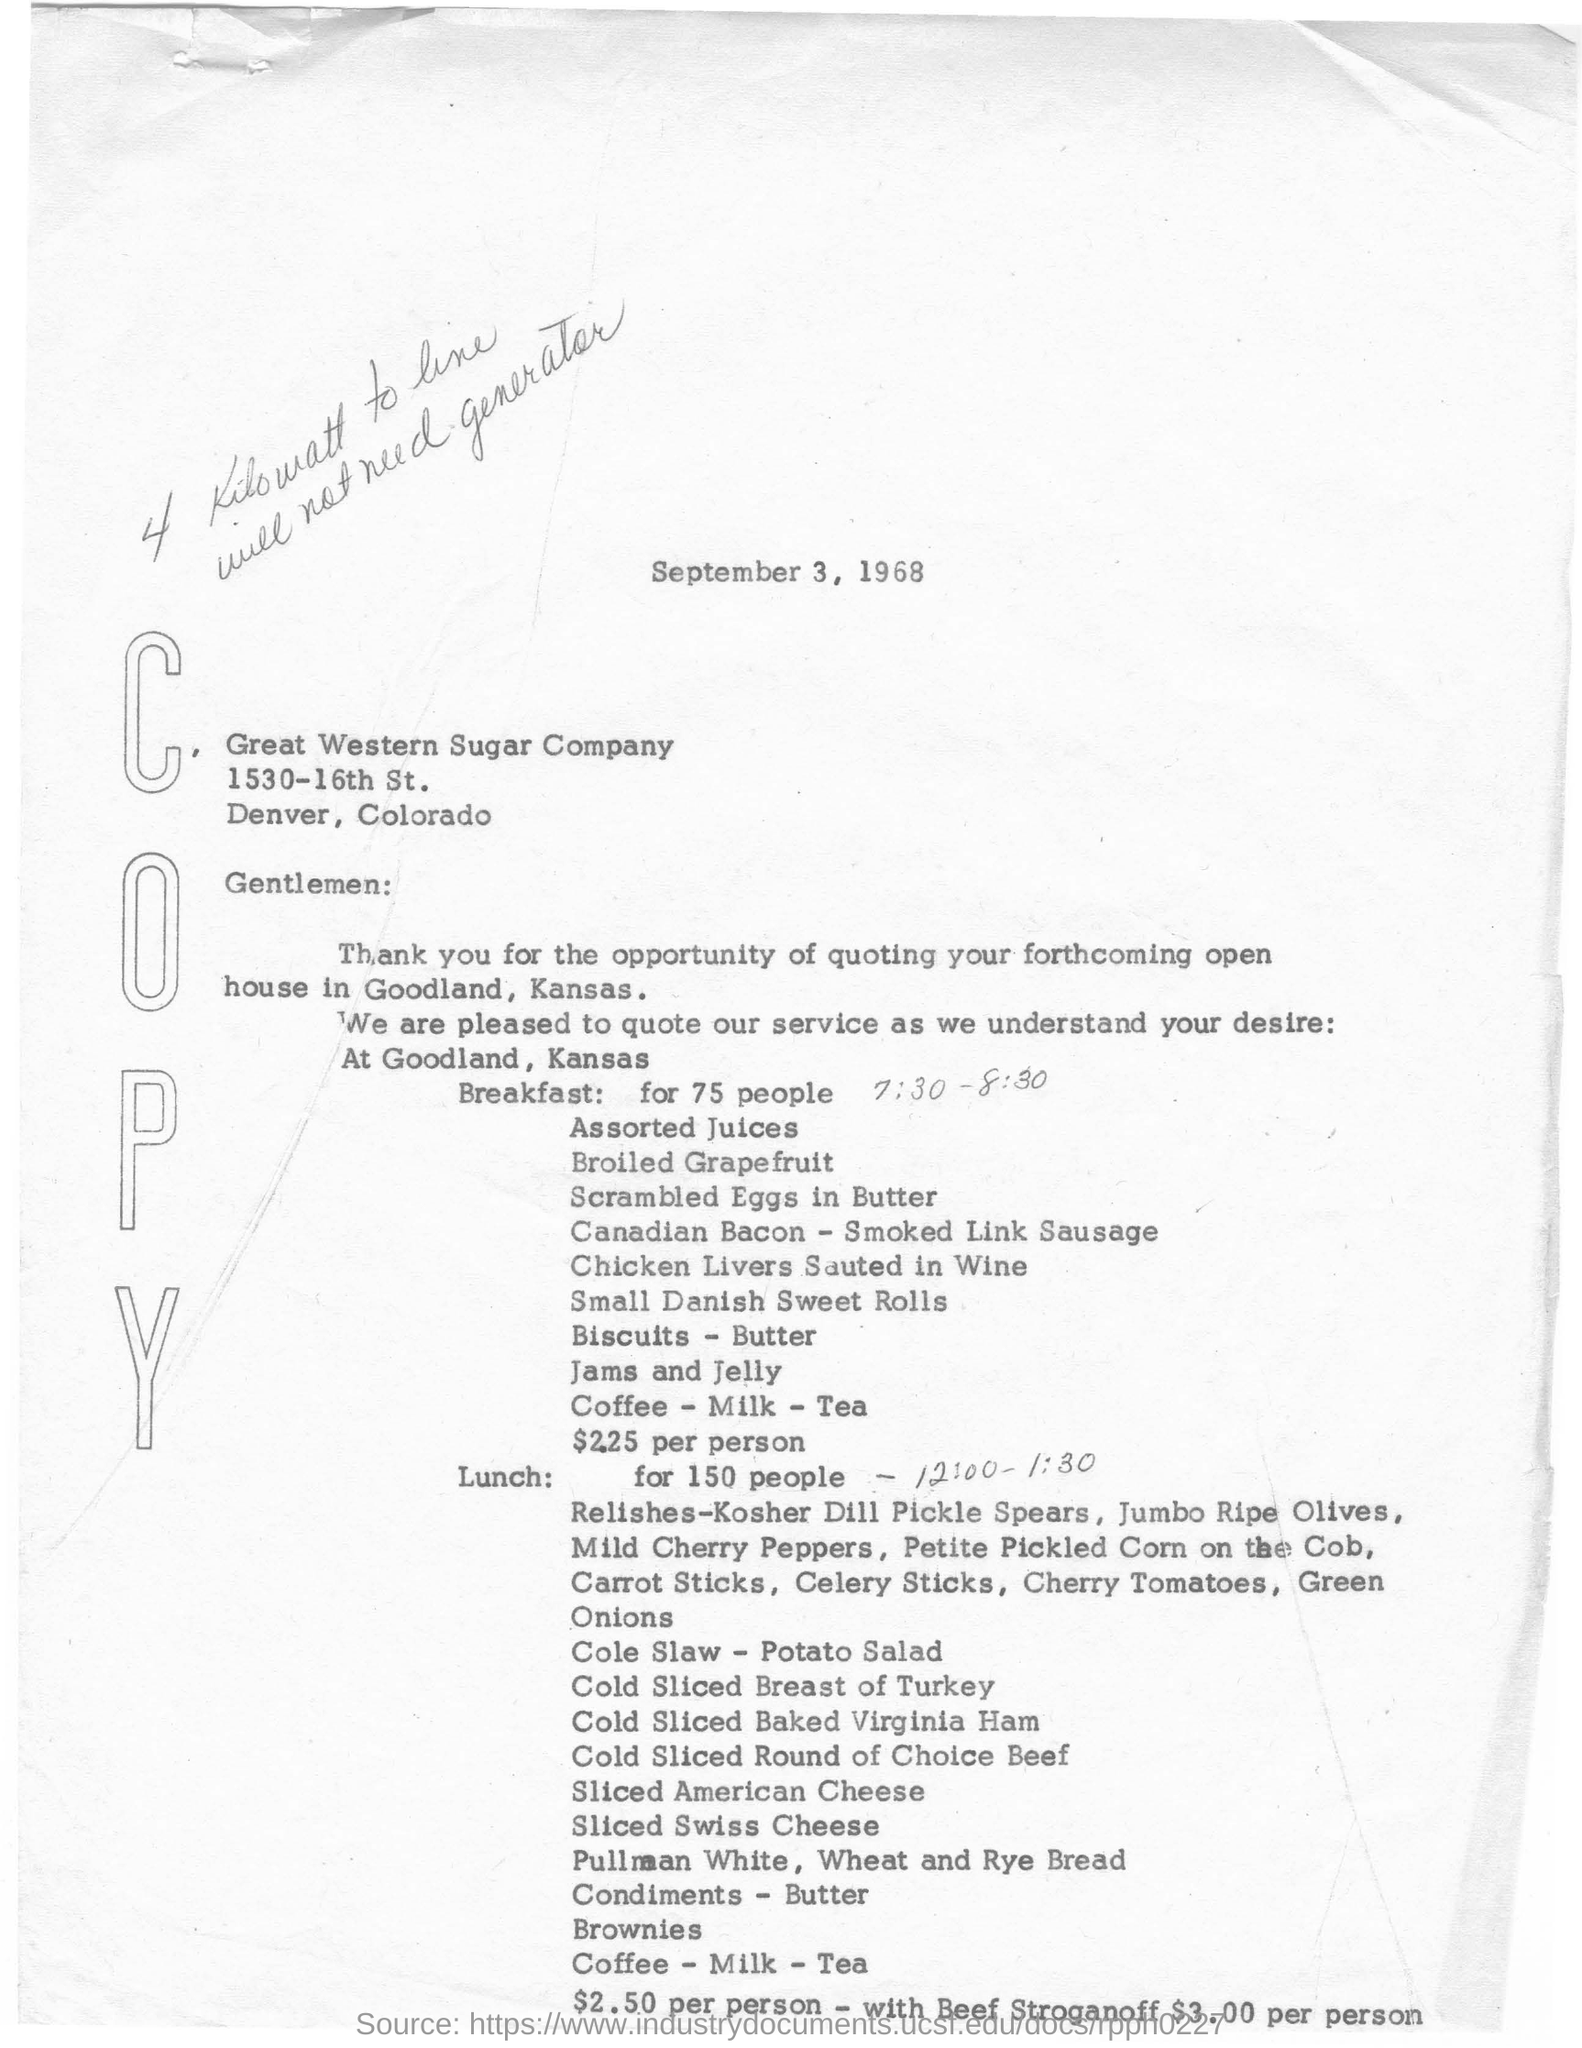What is the Date of the document ?
Your answer should be very brief. September 3, 1968. What is the name of Sugar Company?
Keep it short and to the point. Great Western Sugar Company. Which State the company is located?
Keep it short and to the point. Colorado. What was the provided time for Breakfast?
Ensure brevity in your answer.  7:30 - 8:30. For how many people the breakfast was arranged?
Provide a short and direct response. 75 people. How much $ per person was quoted for the breakfast ?
Keep it short and to the point. 2.25. What was the provided time for Lunch?
Make the answer very short. 12:00 - 1:30. For how many people the Lunch was arranged?
Provide a short and direct response. 150 people. With 'Beef Stroganoff' how much was per person amount for lunch in $?
Your answer should be very brief. $3.00. 